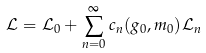<formula> <loc_0><loc_0><loc_500><loc_500>\mathcal { L } = \mathcal { L } _ { 0 } + \sum _ { n = 0 } ^ { \infty } c _ { n } ( g _ { 0 } , m _ { 0 } ) \mathcal { L } _ { n }</formula> 